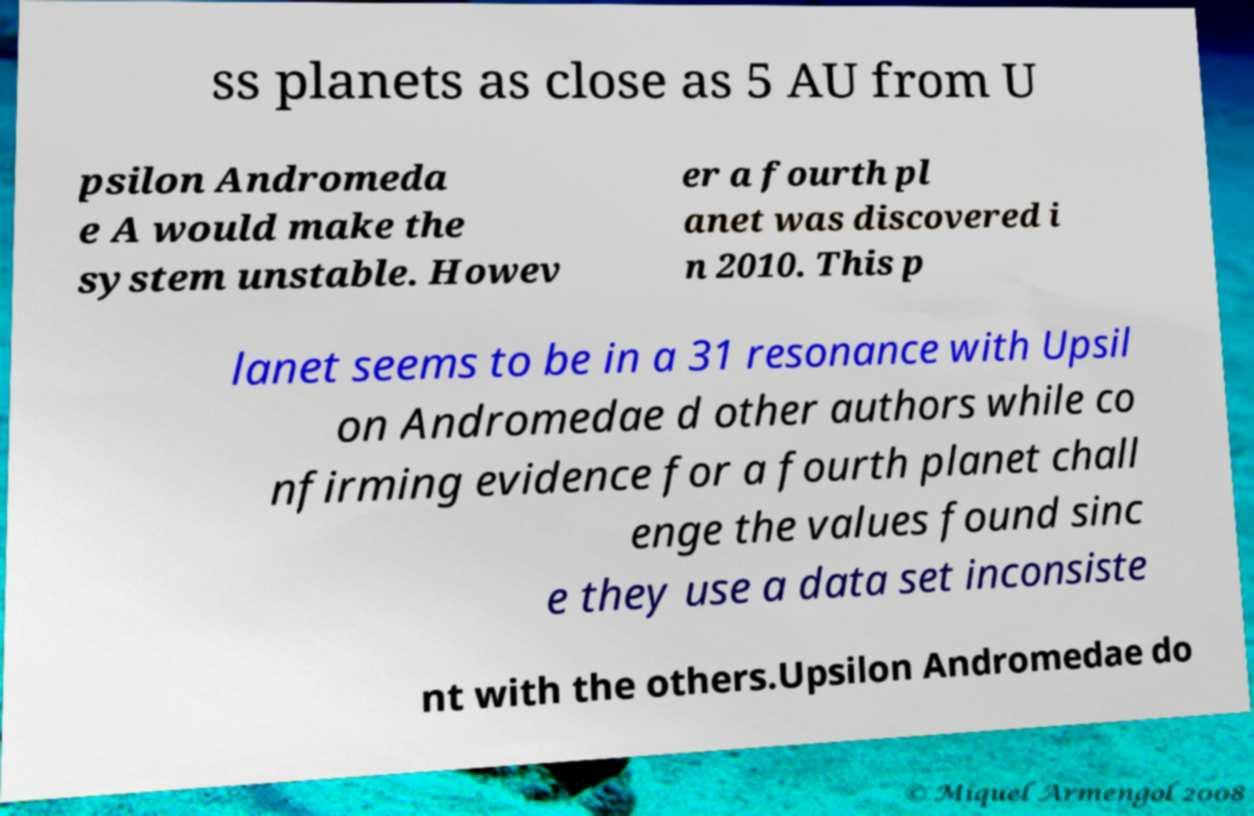For documentation purposes, I need the text within this image transcribed. Could you provide that? ss planets as close as 5 AU from U psilon Andromeda e A would make the system unstable. Howev er a fourth pl anet was discovered i n 2010. This p lanet seems to be in a 31 resonance with Upsil on Andromedae d other authors while co nfirming evidence for a fourth planet chall enge the values found sinc e they use a data set inconsiste nt with the others.Upsilon Andromedae do 